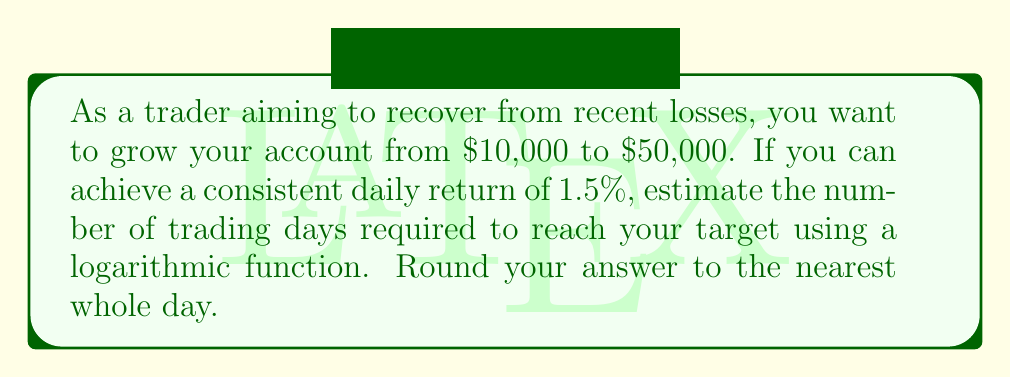Can you answer this question? Let's approach this step-by-step:

1) We can model this growth using the compound interest formula:
   $A = P(1 + r)^t$
   Where:
   $A$ = final amount
   $P$ = principal (initial investment)
   $r$ = daily rate of return
   $t$ = number of days

2) We know:
   $A = 50000$
   $P = 10000$
   $r = 0.015$ (1.5% expressed as a decimal)

3) Substituting these values:
   $50000 = 10000(1 + 0.015)^t$

4) Dividing both sides by 10000:
   $5 = (1.015)^t$

5) To solve for $t$, we need to use logarithms. Taking the natural log of both sides:
   $\ln(5) = t \cdot \ln(1.015)$

6) Solving for $t$:
   $t = \frac{\ln(5)}{\ln(1.015)}$

7) Using a calculator:
   $t \approx 107.8731$

8) Rounding to the nearest whole day:
   $t = 108$ days
Answer: 108 days 